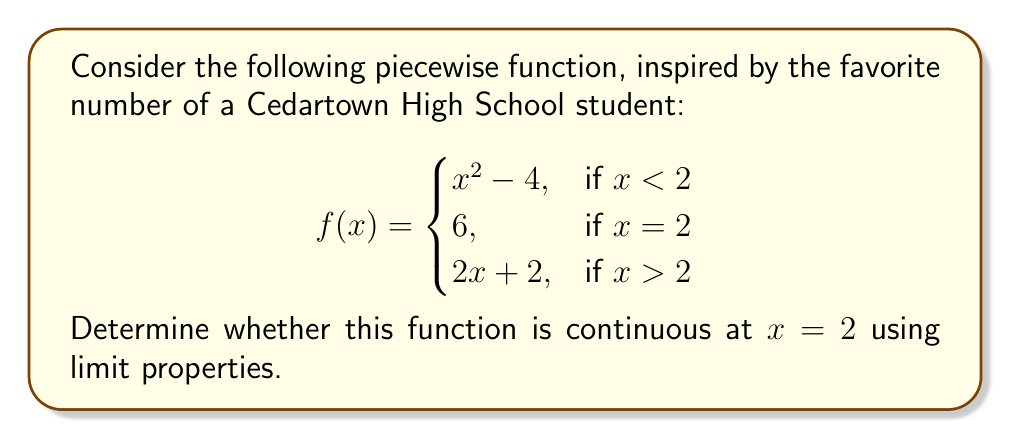Can you solve this math problem? To determine the continuity of the function at $x = 2$, we need to check three conditions:

1. The function must be defined at $x = 2$
2. The limit of the function as $x$ approaches 2 from both sides must exist
3. The limit must equal the function value at $x = 2$

Let's check each condition:

1. The function is defined at $x = 2$, as $f(2) = 6$

2. We need to find the left-hand and right-hand limits:

   Left-hand limit:
   $$\lim_{x \to 2^-} f(x) = \lim_{x \to 2^-} (x^2 - 4) = 2^2 - 4 = 0$$

   Right-hand limit:
   $$\lim_{x \to 2^+} f(x) = \lim_{x \to 2^+} (2x + 2) = 2(2) + 2 = 6$$

   The left-hand and right-hand limits are not equal, so the limit does not exist.

3. Since the limit does not exist, we don't need to check if it equals $f(2)$

Because the second condition is not met (the limit does not exist), we can conclude that the function is not continuous at $x = 2$.
Answer: The function $f(x)$ is not continuous at $x = 2$. 